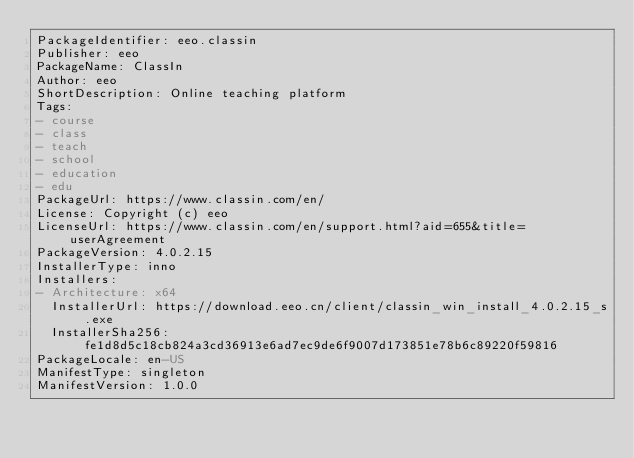Convert code to text. <code><loc_0><loc_0><loc_500><loc_500><_YAML_>PackageIdentifier: eeo.classin
Publisher: eeo
PackageName: ClassIn
Author: eeo
ShortDescription: Online teaching platform
Tags:
- course
- class
- teach
- school
- education
- edu
PackageUrl: https://www.classin.com/en/
License: Copyright (c) eeo
LicenseUrl: https://www.classin.com/en/support.html?aid=655&title=userAgreement
PackageVersion: 4.0.2.15
InstallerType: inno
Installers:
- Architecture: x64
  InstallerUrl: https://download.eeo.cn/client/classin_win_install_4.0.2.15_s.exe
  InstallerSha256: fe1d8d5c18cb824a3cd36913e6ad7ec9de6f9007d173851e78b6c89220f59816
PackageLocale: en-US
ManifestType: singleton
ManifestVersion: 1.0.0
</code> 